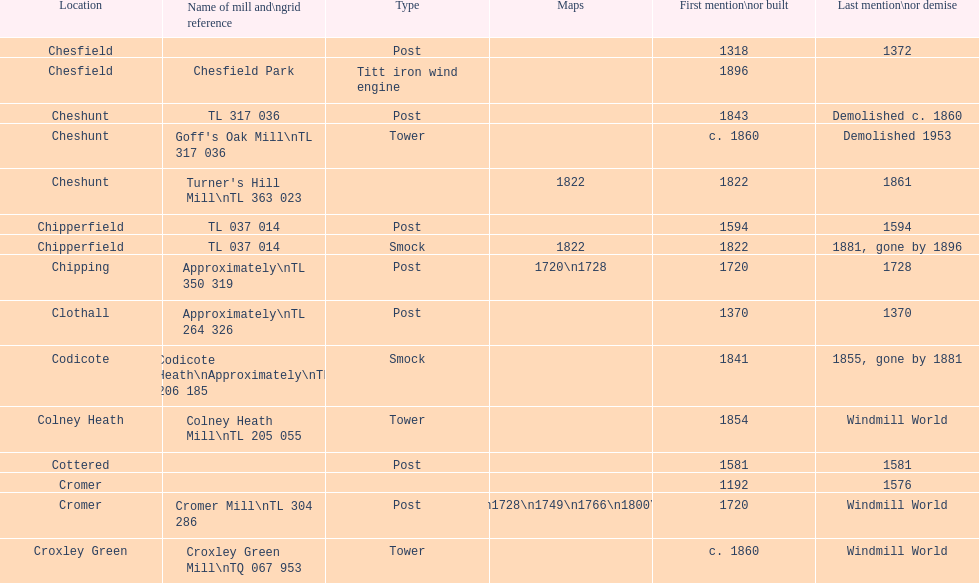At how many sites can you find or once found at least 2 windmills? 4. 